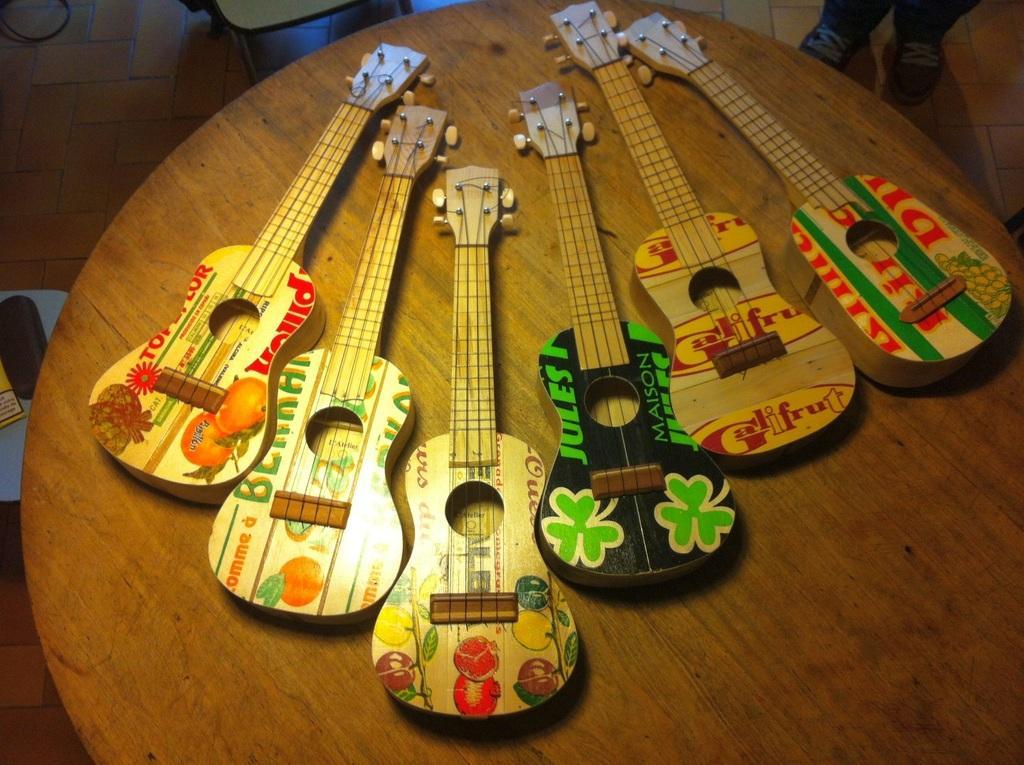Please provide a concise description of this image. As we can see in the picture that there is a circular table on which six guitars are placed. Beside the table there is a man is standing. This is a floor and tiles. 